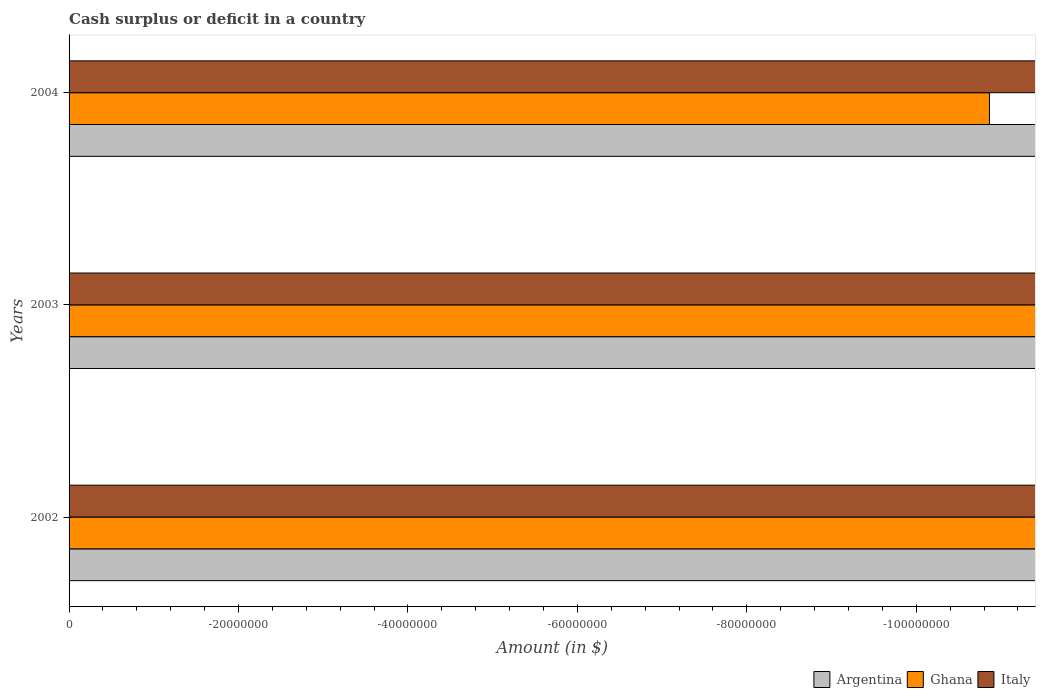How many different coloured bars are there?
Offer a terse response. 0. How many bars are there on the 3rd tick from the top?
Give a very brief answer. 0. How many bars are there on the 2nd tick from the bottom?
Make the answer very short. 0. What is the amount of cash surplus or deficit in Ghana in 2002?
Your answer should be compact. 0. What is the total amount of cash surplus or deficit in Argentina in the graph?
Provide a short and direct response. 0. What is the difference between the amount of cash surplus or deficit in Italy in 2004 and the amount of cash surplus or deficit in Argentina in 2002?
Offer a very short reply. 0. What is the average amount of cash surplus or deficit in Ghana per year?
Your answer should be compact. 0. In how many years, is the amount of cash surplus or deficit in Italy greater than -100000000 $?
Keep it short and to the point. 0. In how many years, is the amount of cash surplus or deficit in Ghana greater than the average amount of cash surplus or deficit in Ghana taken over all years?
Your answer should be compact. 0. How many bars are there?
Offer a terse response. 0. Are all the bars in the graph horizontal?
Keep it short and to the point. Yes. How many years are there in the graph?
Offer a very short reply. 3. What is the difference between two consecutive major ticks on the X-axis?
Ensure brevity in your answer.  2.00e+07. Does the graph contain any zero values?
Make the answer very short. Yes. Does the graph contain grids?
Your answer should be very brief. No. How are the legend labels stacked?
Offer a terse response. Horizontal. What is the title of the graph?
Provide a succinct answer. Cash surplus or deficit in a country. What is the label or title of the X-axis?
Provide a succinct answer. Amount (in $). What is the Amount (in $) in Ghana in 2002?
Offer a very short reply. 0. What is the Amount (in $) in Argentina in 2003?
Give a very brief answer. 0. What is the Amount (in $) of Argentina in 2004?
Provide a short and direct response. 0. What is the Amount (in $) in Ghana in 2004?
Provide a short and direct response. 0. What is the total Amount (in $) in Argentina in the graph?
Provide a short and direct response. 0. What is the average Amount (in $) in Argentina per year?
Your answer should be compact. 0. What is the average Amount (in $) of Italy per year?
Your answer should be compact. 0. 